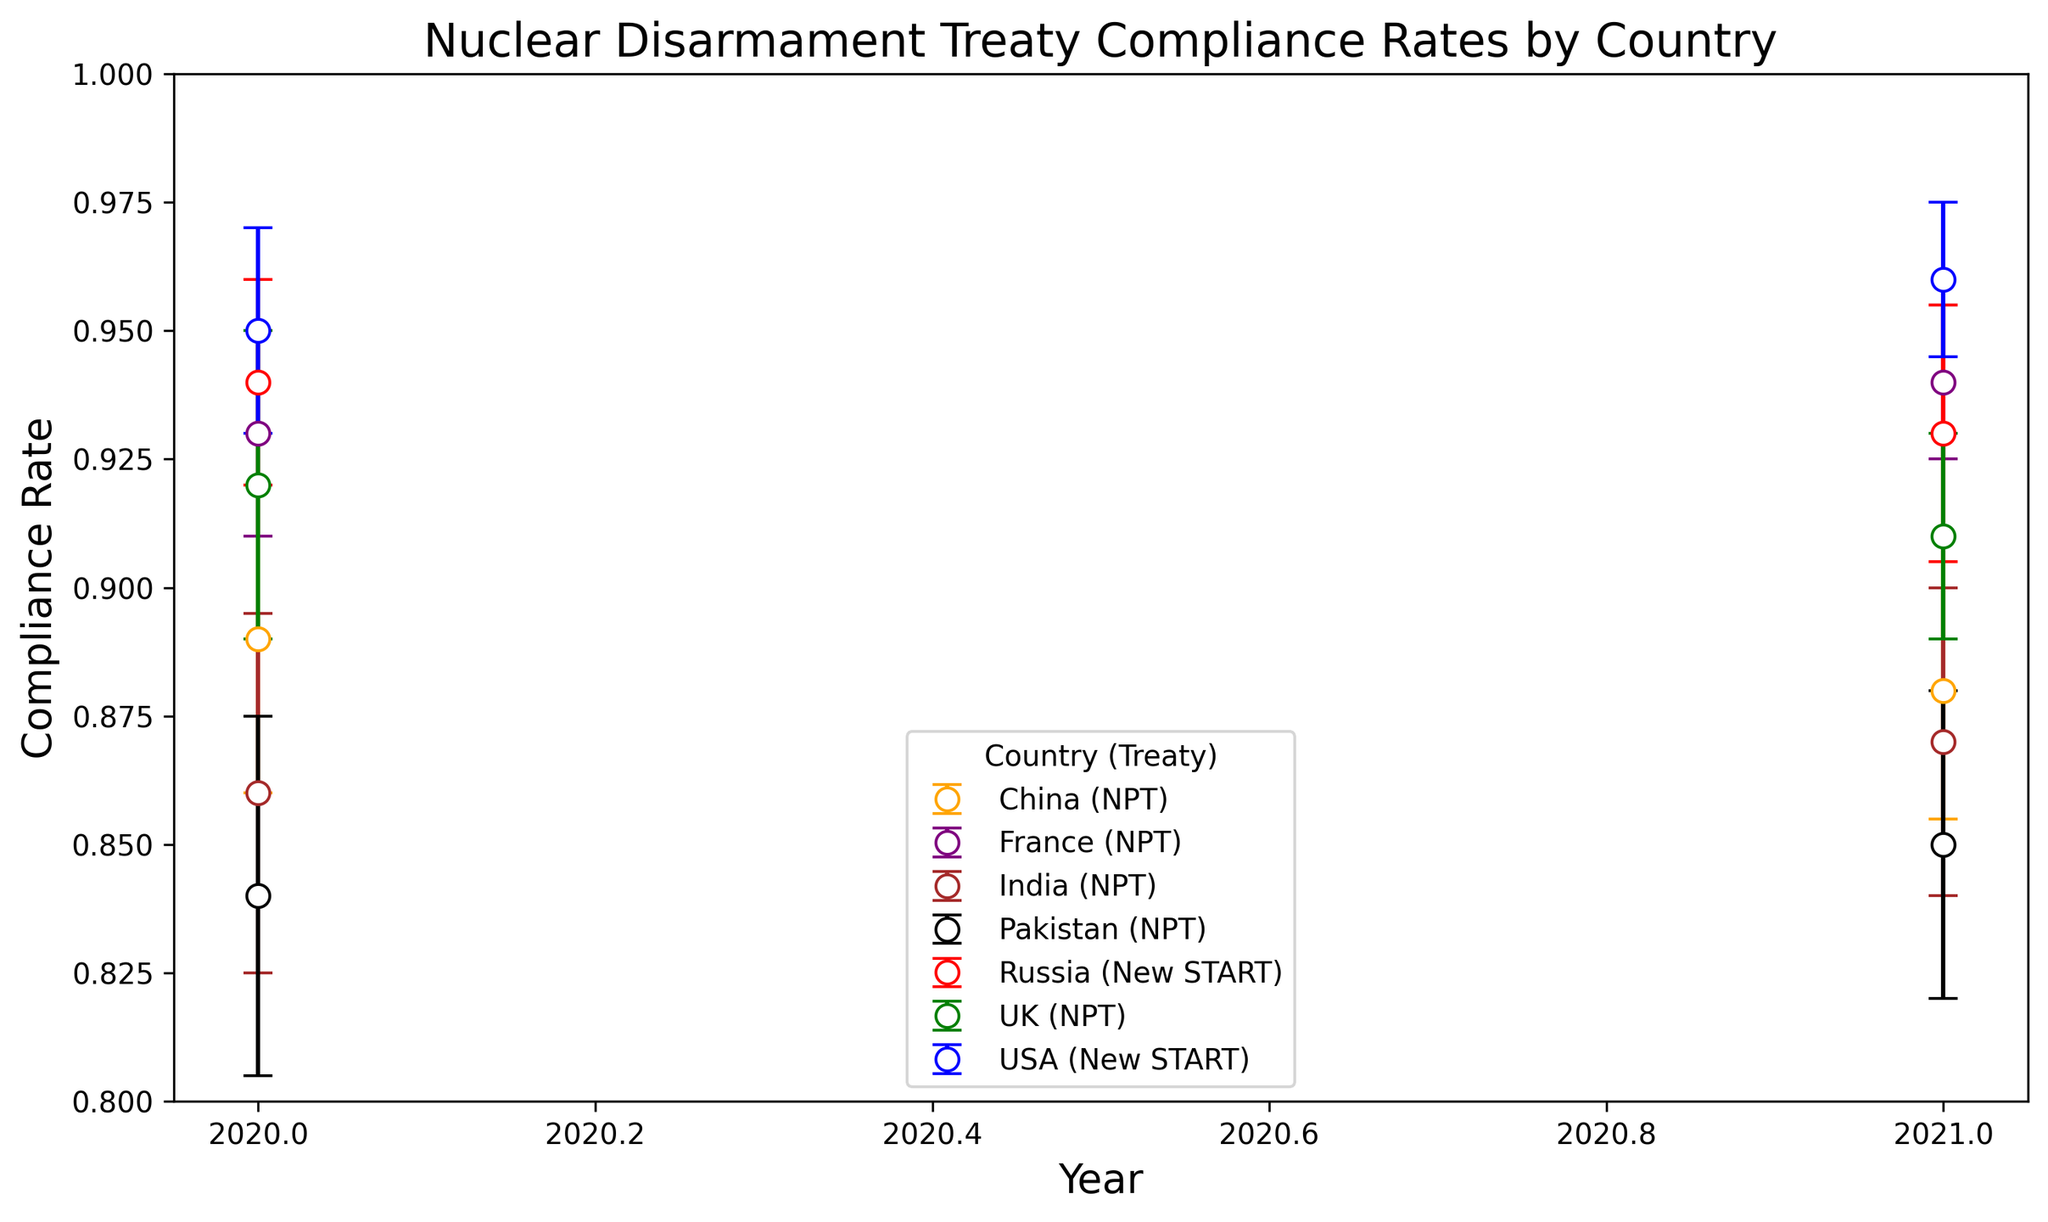What is the overall trend in compliance rates for the USA in the years shown? The plot shows the compliance rates for the USA for the years 2020 and 2021. To find the trend, observe the compliance rates for these years. In 2020, the compliance rate is 0.95, and in 2021, it is 0.96. Since the rate increased from 0.95 to 0.96, the overall trend is increasing.
Answer: Increasing Which country had the lowest compliance rate in 2020? To determine the country with the lowest compliance rate in 2020, look at the compliance rates for all countries in that year. The rates are: USA (0.95), Russia (0.94), UK (0.92), France (0.93), China (0.89), India (0.86), Pakistan (0.84). Pakistan has the lowest rate at 0.84.
Answer: Pakistan Comparing the UK and France, which country showed a higher improvement in compliance rates from 2020 to 2021? To compare the improvement, calculate the difference in compliance rates for both countries between 2020 and 2021. For the UK: 0.91 (2021) - 0.92 (2020) = -0.01 (a decrease). For France: 0.94 (2021) - 0.93 (2020) = 0.01 (an increase). France showed an improvement.
Answer: France What was the compliance rate of China in 2021, and how does it compare to its compliance rate in 2020? China's compliance rate in 2021 is 0.88, and in 2020 it was 0.89. Comparing these values, 0.88 (2021) is less than 0.89 (2020), indicating a decrease.
Answer: 0.88, decreased Which countries had compliance rates over 90% in both 2020 and 2021? Examine the compliance rates for each country in both years. USA has 0.95 (2020) and 0.96 (2021). Russia has 0.94 (2020) and 0.93 (2021). The UK has 0.92 (2020) and 0.91 (2021). France has 0.93 (2020) and 0.94 (2021). Only the USA, Russia, UK, and France meet this criteria as their rates remained above 0.90 for both years.
Answer: USA, Russia, UK, France What is the difference between the highest and lowest compliance rates in 2021? First, identify the highest and lowest compliance rates in 2021. The highest rates are USA (0.96) and France (0.94). The lowest rates are China (0.88) and Pakistan (0.85). The difference between the highest (0.96) and the lowest (0.85) is 0.96 - 0.85 = 0.11.
Answer: 0.11 How did the compliance rate of Pakistan change from 2020 to 2021? Observe the compliance rates for Pakistan. In 2020, it was 0.84, and in 2021 it was 0.85. The change is 0.85 - 0.84 = 0.01, indicating an increase of 0.01.
Answer: Increased by 0.01 Which country had the smallest error in their compliance rate measurement in 2021? To find the smallest error in 2021, look at the error values for that year. USA has 0.015, Russia has 0.025, UK has 0.02, France has 0.015, China has 0.025, India has 0.03, and Pakistan has 0.03. USA and France both have the smallest error of 0.015.
Answer: USA and France In 2020, which country showed a higher compliance rate, China or India? Compare the compliance rates for China and India in 2020. China's rate is 0.89, while India's rate is 0.86. Therefore, China has a higher compliance rate.
Answer: China What was the compliance rate of India in 2021, and did it show improvement compared to 2020? India's compliance rate in 2021 is 0.87, and in 2020 it was 0.86. To check for improvement, calculate the difference: 0.87 - 0.86 = 0.01. The rate improved by 0.01.
Answer: 0.87, improved 